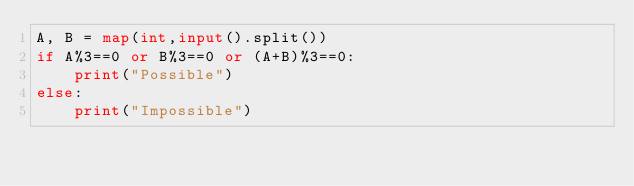<code> <loc_0><loc_0><loc_500><loc_500><_Python_>A, B = map(int,input().split())
if A%3==0 or B%3==0 or (A+B)%3==0:
    print("Possible")
else:
    print("Impossible")</code> 